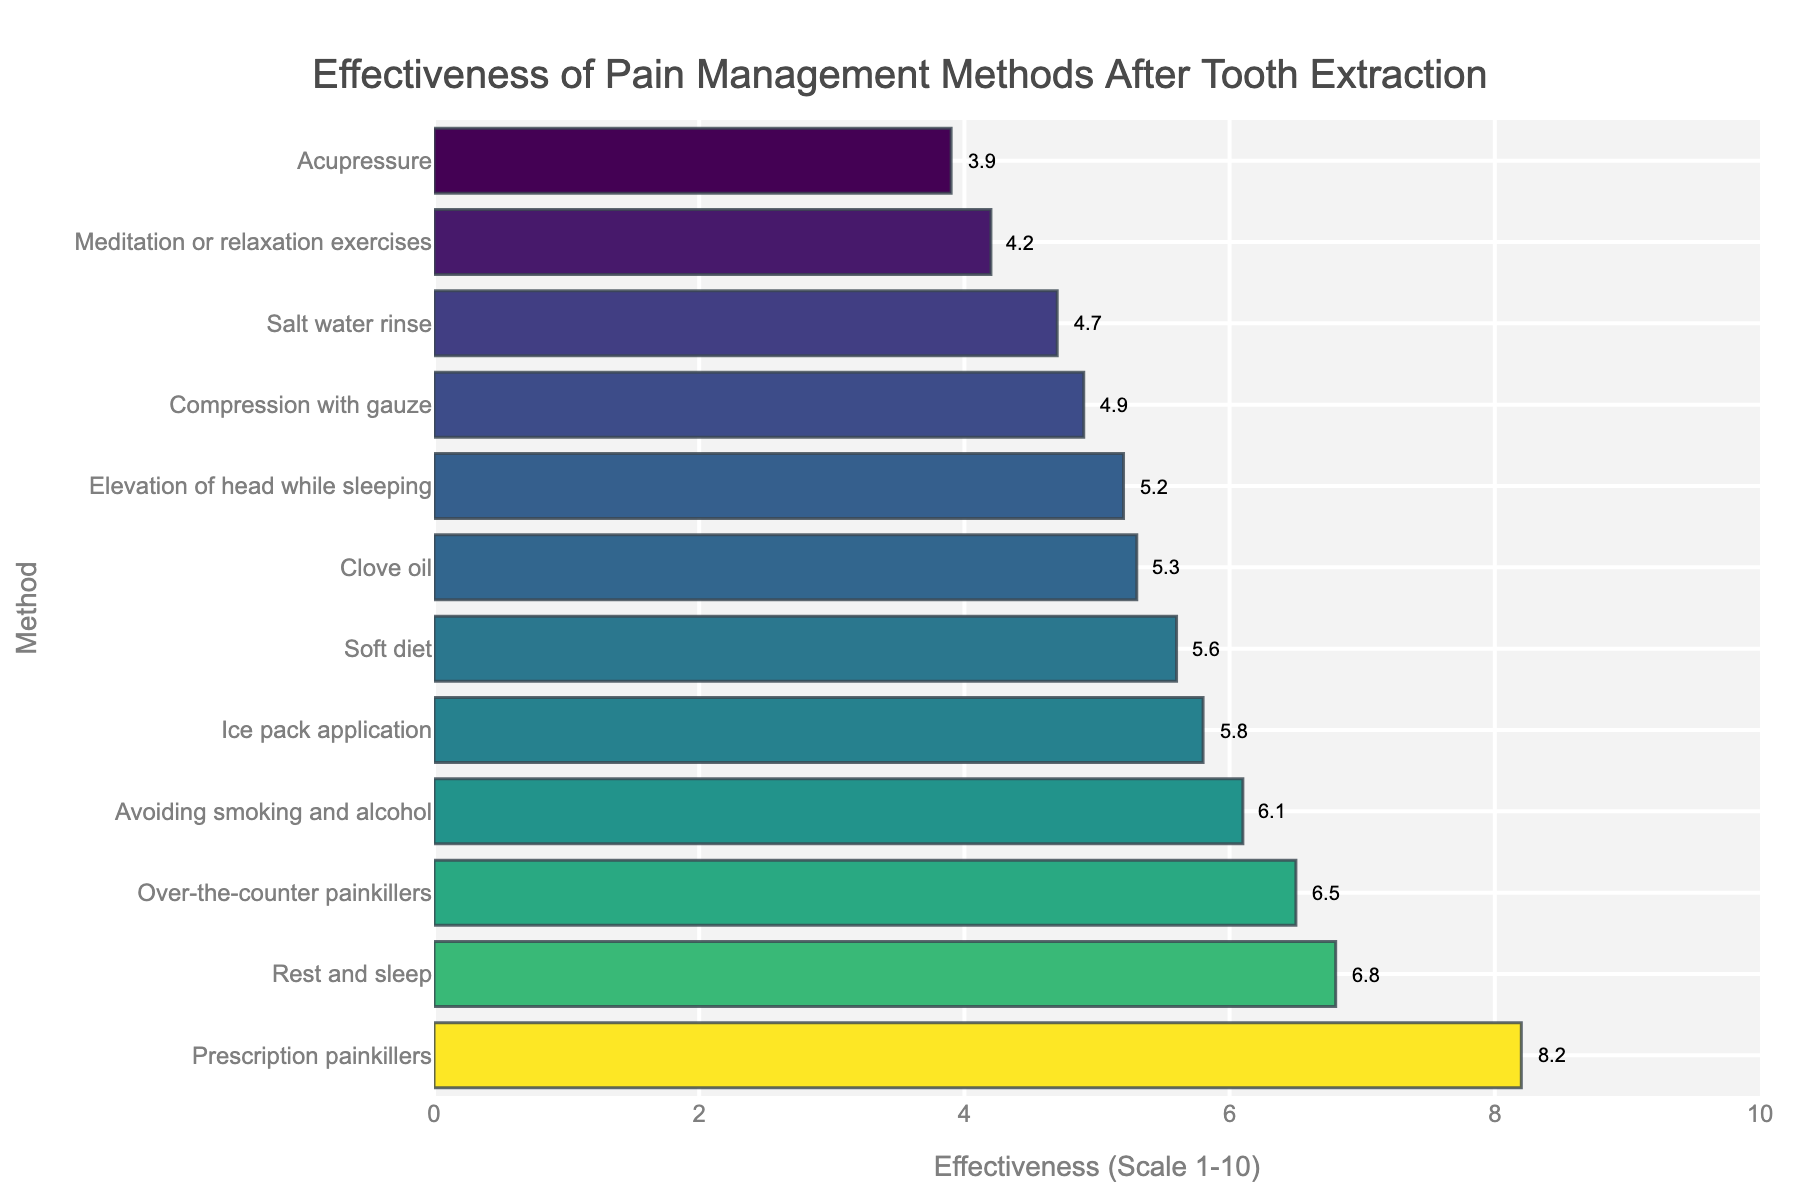What are the top three most effective pain management methods after tooth extraction? Look at the bar chart and find the three methods with the highest effectiveness scores.
Answer: Prescription painkillers, Rest and sleep, Over-the-counter painkillers Which method is more effective: Ice pack application or Salt water rinse? Compare the positions of the bars representing 'Ice pack application' and 'Salt water rinse' and their effectiveness scores.
Answer: Ice pack application What is the average effectiveness of Rest and sleep and Elevation of head while sleeping? Sum the effectiveness scores of 'Rest and sleep' and 'Elevation of head while sleeping' and divide by 2.
Answer: (6.8 + 5.2) / 2 = 6.0 Which pain management method has the lowest effectiveness? Find the bar with the lowest effectiveness score.
Answer: Acupressure How much more effective are Prescription painkillers compared to Clove oil? Subtract the effectiveness score of 'Clove oil' from 'Prescription painkillers'.
Answer: 8.2 - 5.3 = 2.9 What is the combined effectiveness score of Soft diet, Compression with gauze, and Avoiding smoking and alcohol? Sum the effectiveness scores of 'Soft diet', 'Compression with gauze', and 'Avoiding smoking and alcohol'.
Answer: 5.6 + 4.9 + 6.1 = 16.6 Are Meditation or relaxation exercises more or less effective than Salt water rinse? Compare the positions of the bars representing 'Meditation or relaxation exercises' and 'Salt water rinse' and their effectiveness scores.
Answer: Less effective Which method has a similar effectiveness to Clove oil? Identify a method with an effectiveness score close to 5.3.
Answer: Elevation of head while sleeping What is the difference in effectiveness between the most effective and the least effective method? Subtract the lowest effectiveness score from the highest effectiveness score.
Answer: 8.2 - 3.9 = 4.3 